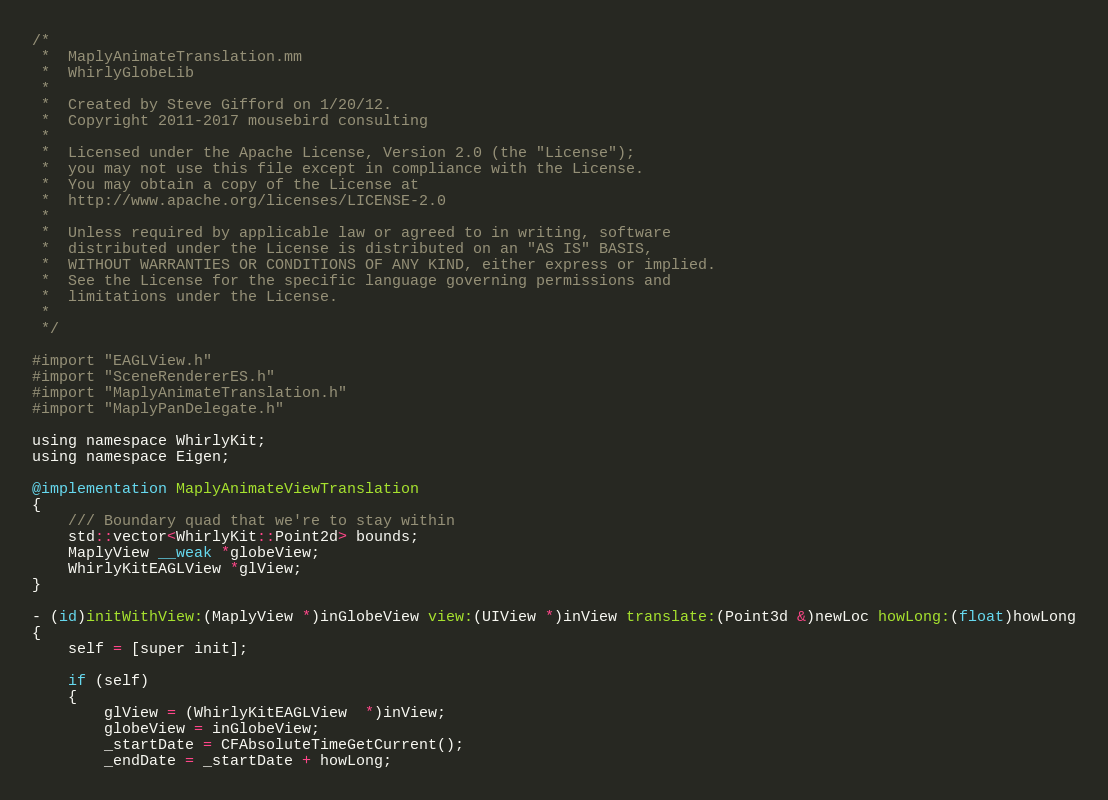Convert code to text. <code><loc_0><loc_0><loc_500><loc_500><_ObjectiveC_>/*
 *  MaplyAnimateTranslation.mm
 *  WhirlyGlobeLib
 *
 *  Created by Steve Gifford on 1/20/12.
 *  Copyright 2011-2017 mousebird consulting
 *
 *  Licensed under the Apache License, Version 2.0 (the "License");
 *  you may not use this file except in compliance with the License.
 *  You may obtain a copy of the License at
 *  http://www.apache.org/licenses/LICENSE-2.0
 *
 *  Unless required by applicable law or agreed to in writing, software
 *  distributed under the License is distributed on an "AS IS" BASIS,
 *  WITHOUT WARRANTIES OR CONDITIONS OF ANY KIND, either express or implied.
 *  See the License for the specific language governing permissions and
 *  limitations under the License.
 *
 */

#import "EAGLView.h"
#import "SceneRendererES.h"
#import "MaplyAnimateTranslation.h"
#import "MaplyPanDelegate.h"

using namespace WhirlyKit;
using namespace Eigen;

@implementation MaplyAnimateViewTranslation
{
    /// Boundary quad that we're to stay within
    std::vector<WhirlyKit::Point2d> bounds;
    MaplyView __weak *globeView;
    WhirlyKitEAGLView *glView;
}

- (id)initWithView:(MaplyView *)inGlobeView view:(UIView *)inView translate:(Point3d &)newLoc howLong:(float)howLong
{
    self = [super init];
    
    if (self)
    {
        glView = (WhirlyKitEAGLView  *)inView;
        globeView = inGlobeView;
        _startDate = CFAbsoluteTimeGetCurrent();
        _endDate = _startDate + howLong;</code> 